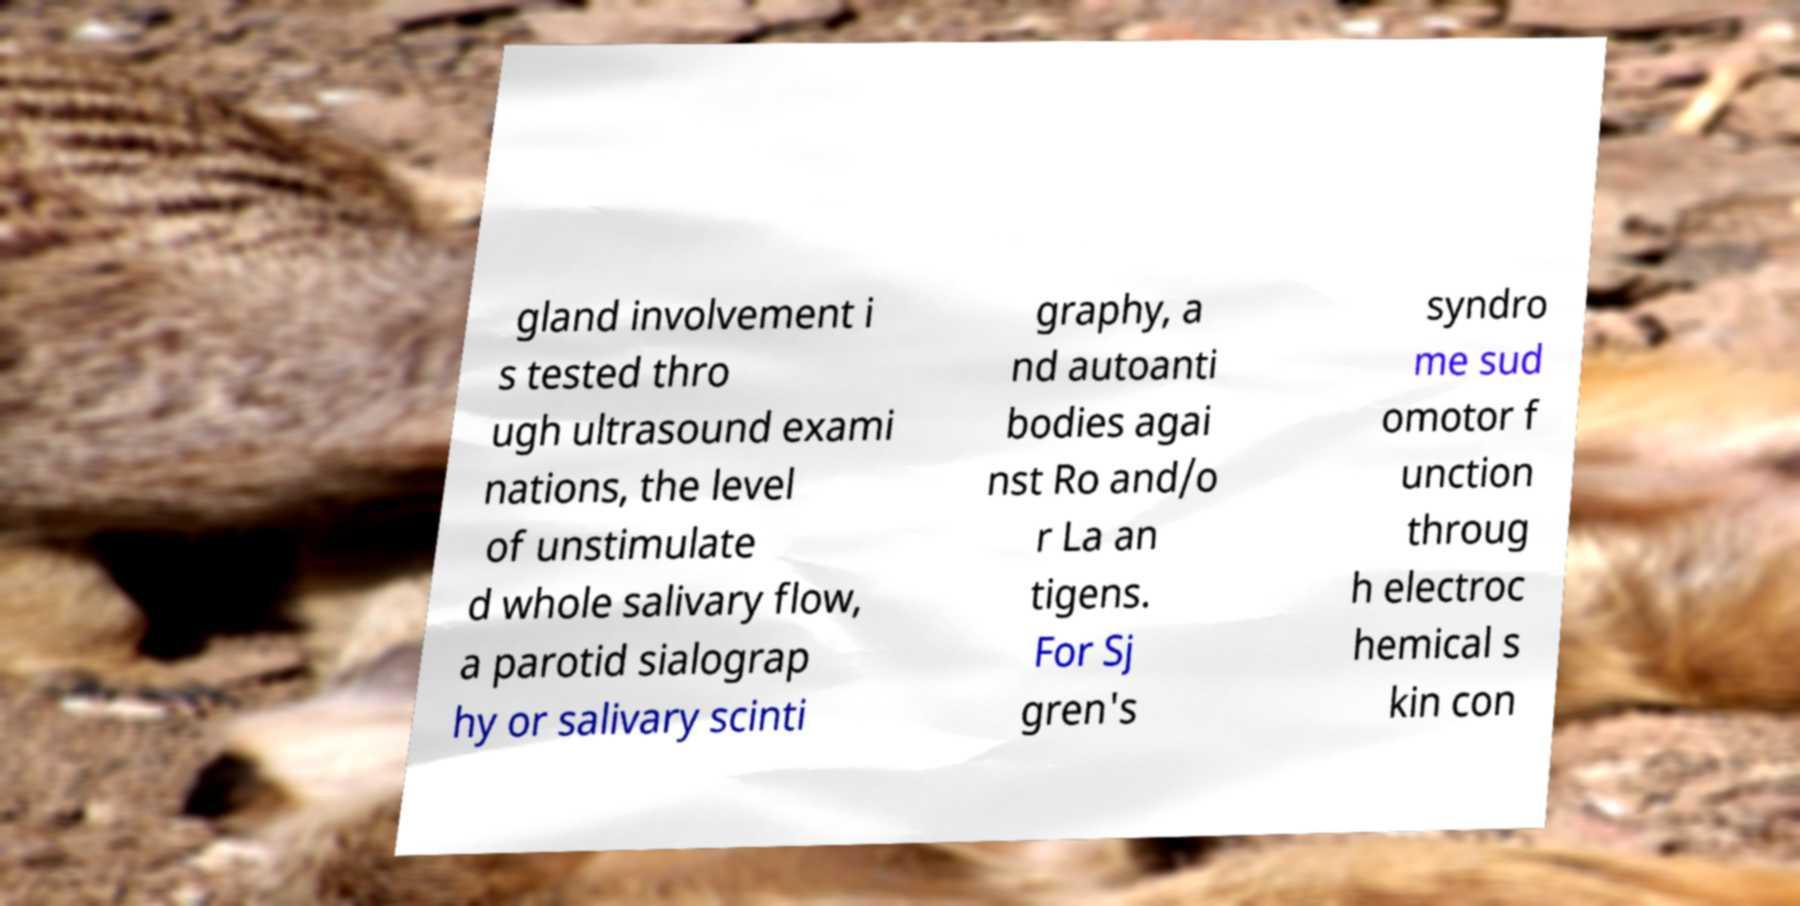Can you read and provide the text displayed in the image?This photo seems to have some interesting text. Can you extract and type it out for me? gland involvement i s tested thro ugh ultrasound exami nations, the level of unstimulate d whole salivary flow, a parotid sialograp hy or salivary scinti graphy, a nd autoanti bodies agai nst Ro and/o r La an tigens. For Sj gren's syndro me sud omotor f unction throug h electroc hemical s kin con 